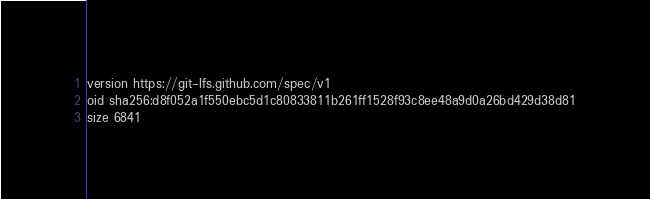Convert code to text. <code><loc_0><loc_0><loc_500><loc_500><_HTML_>version https://git-lfs.github.com/spec/v1
oid sha256:d8f052a1f550ebc5d1c80833811b261ff1528f93c8ee48a9d0a26bd429d38d81
size 6841
</code> 